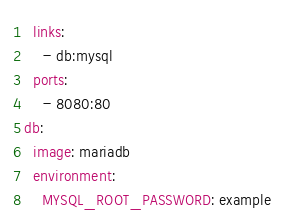Convert code to text. <code><loc_0><loc_0><loc_500><loc_500><_YAML_>  links:
    - db:mysql
  ports:
    - 8080:80
db:
  image: mariadb
  environment:
    MYSQL_ROOT_PASSWORD: example</code> 